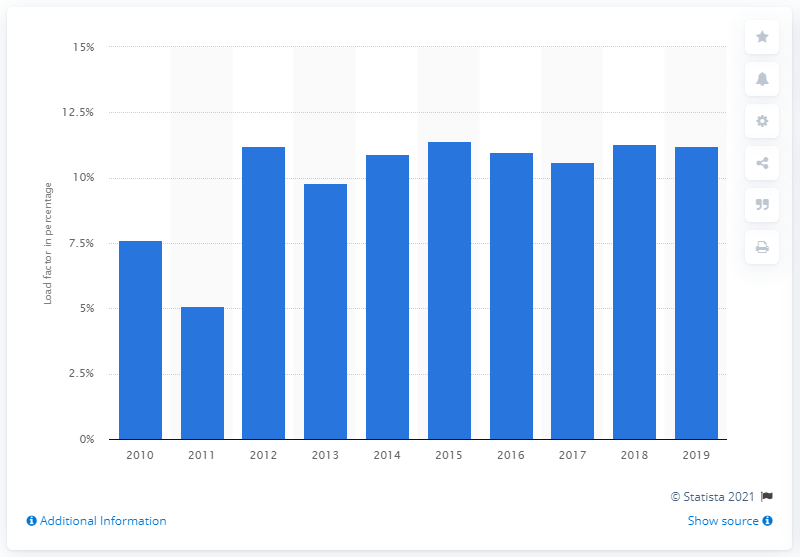Draw attention to some important aspects in this diagram. In 2019, the load factor of electricity generated from solar photovoltaics was 11.2%. 